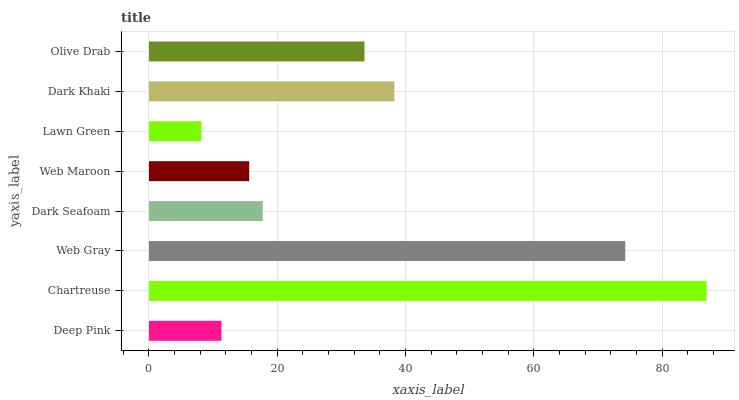Is Lawn Green the minimum?
Answer yes or no. Yes. Is Chartreuse the maximum?
Answer yes or no. Yes. Is Web Gray the minimum?
Answer yes or no. No. Is Web Gray the maximum?
Answer yes or no. No. Is Chartreuse greater than Web Gray?
Answer yes or no. Yes. Is Web Gray less than Chartreuse?
Answer yes or no. Yes. Is Web Gray greater than Chartreuse?
Answer yes or no. No. Is Chartreuse less than Web Gray?
Answer yes or no. No. Is Olive Drab the high median?
Answer yes or no. Yes. Is Dark Seafoam the low median?
Answer yes or no. Yes. Is Deep Pink the high median?
Answer yes or no. No. Is Olive Drab the low median?
Answer yes or no. No. 